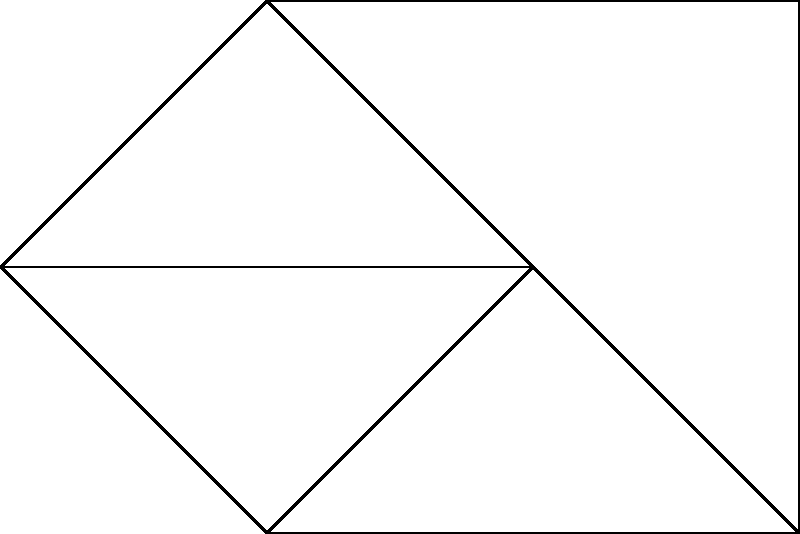Consider the undirected graph shown above. Starting from vertex $v_1$, perform a Depth-First Search (DFS) traversal. Assuming ties are broken by choosing the vertex with the lower index, what is the correct order of vertex visits? To perform a Depth-First Search (DFS) starting from $v_1$, we follow these steps:

1. Start at $v_1$. Mark it as visited.
2. From $v_1$, we have three choices: $v_2$, $v_3$, and $v_4$. We choose the lowest index, $v_2$.
3. From $v_2$, we can visit $v_3$ or $v_5$. We choose $v_3$.
4. From $v_3$, we can visit $v_4$ or $v_6$. We choose $v_4$.
5. From $v_4$, we can only visit $v_6$ as all others are visited.
6. From $v_6$, we can visit $v_5$.
7. All vertices have been visited, so the traversal ends.

The DFS traversal order is therefore: $v_1, v_2, v_3, v_4, v_6, v_5$.

This problem demonstrates the fundamental principle of DFS: to explore as far as possible along each branch before backtracking. It also shows how the algorithm handles decision-making when multiple unvisited neighbors are available, which is crucial for understanding its behavior in more complex graphs.
Answer: $v_1, v_2, v_3, v_4, v_6, v_5$ 